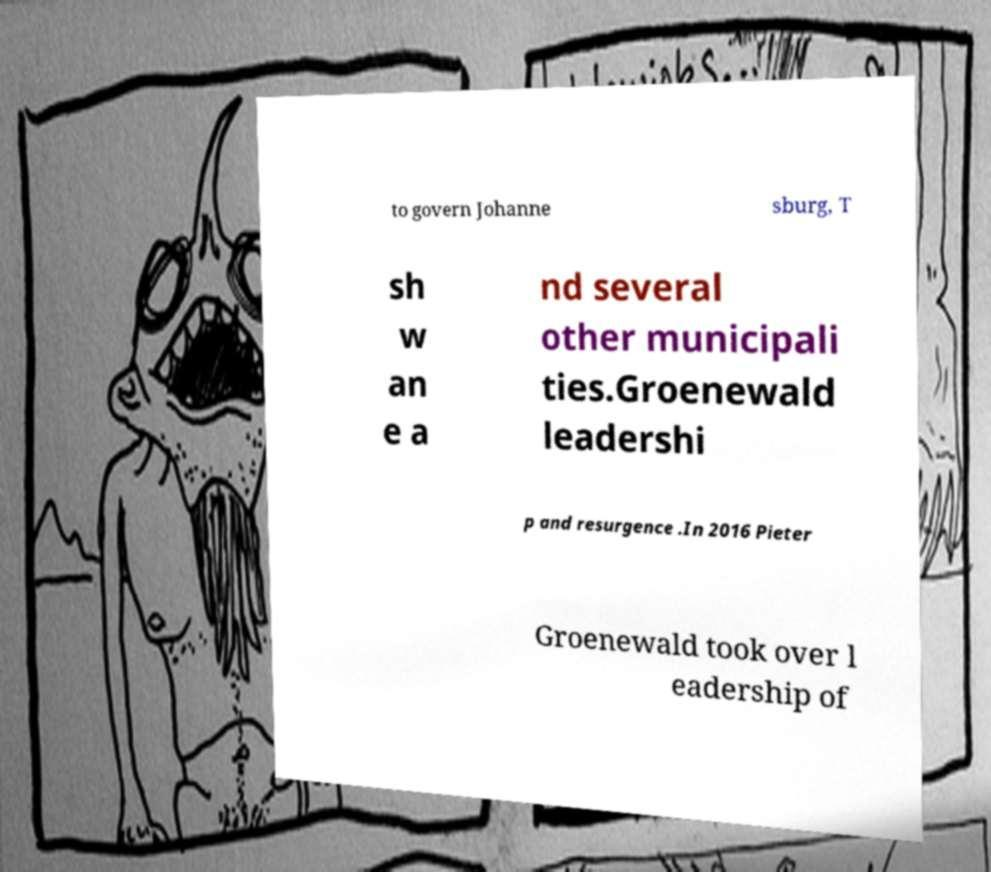Could you extract and type out the text from this image? to govern Johanne sburg, T sh w an e a nd several other municipali ties.Groenewald leadershi p and resurgence .In 2016 Pieter Groenewald took over l eadership of 